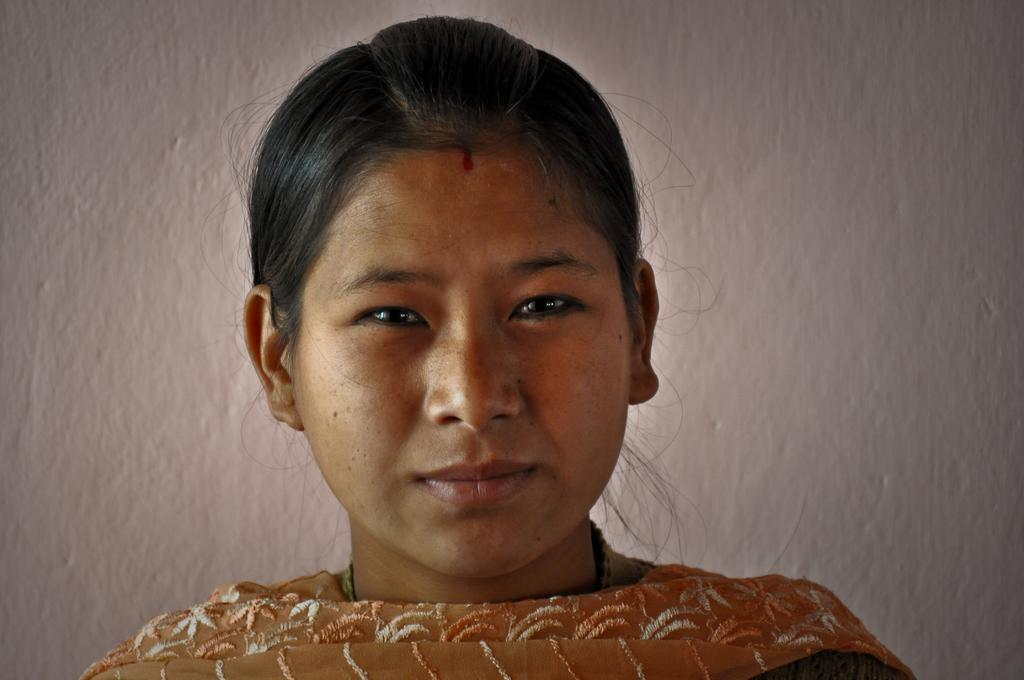Who or what is the main subject in the image? There is a person in the image. Can you describe the position of the person in the image? The person is in front. What can be seen behind the person in the image? There is a wall behind the person. What type of heart can be seen beating in the image? There is no heart visible in the image; it only features a person in front of a wall. 